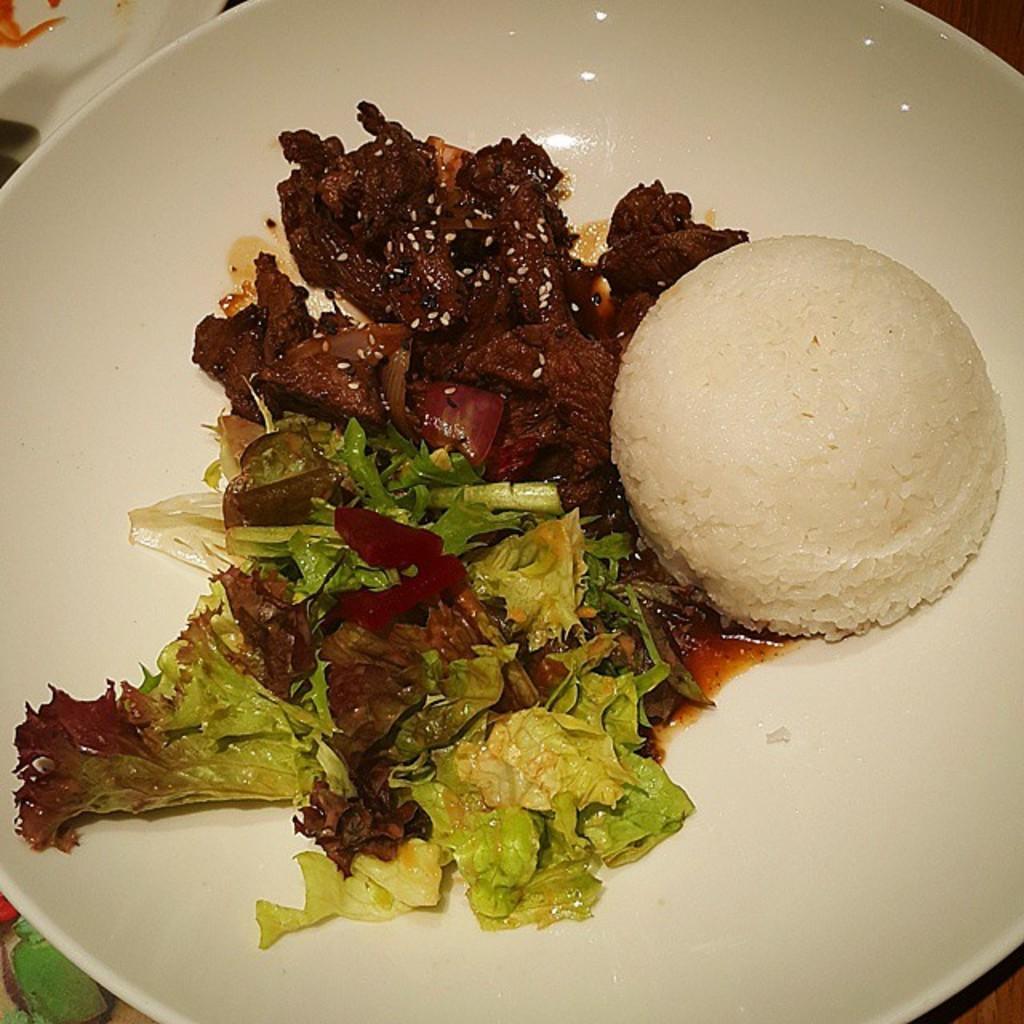Could you give a brief overview of what you see in this image? Here I can see a plate which consists of some food item in it. 